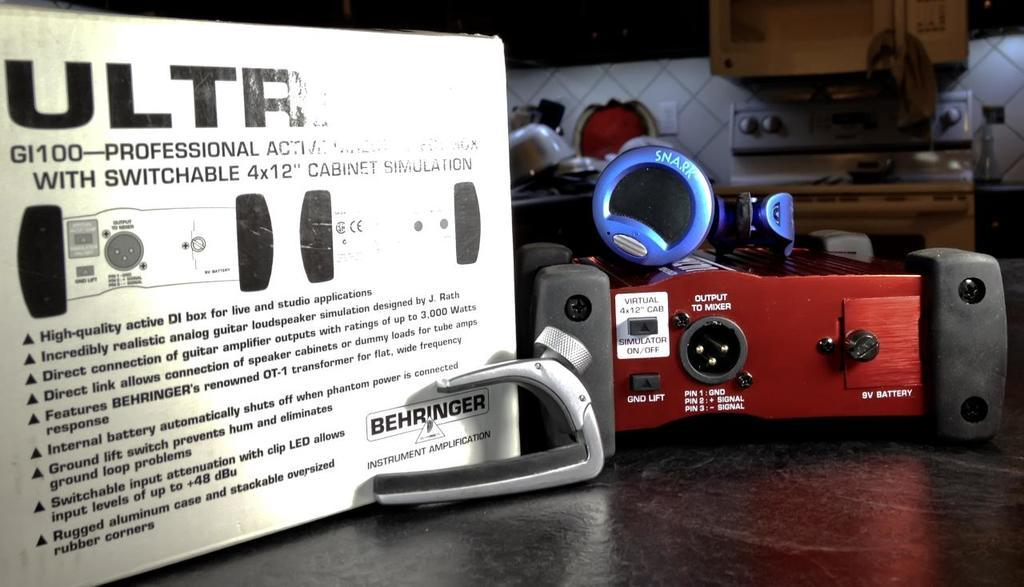<image>
Describe the image concisely. an ad for ULTR with the equipment on a table 